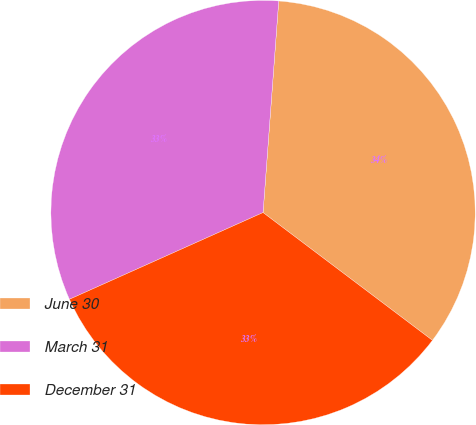Convert chart to OTSL. <chart><loc_0><loc_0><loc_500><loc_500><pie_chart><fcel>June 30<fcel>March 31<fcel>December 31<nl><fcel>34.11%<fcel>32.88%<fcel>33.01%<nl></chart> 